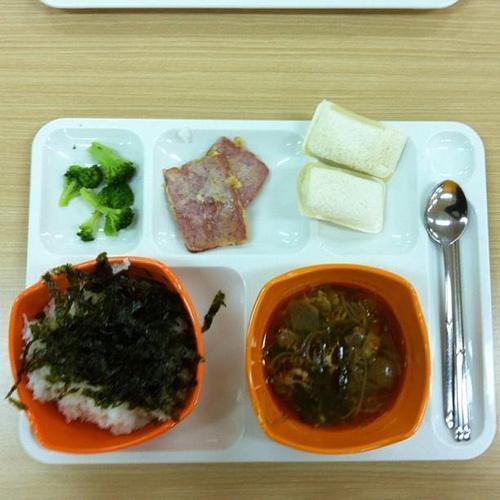How many egg rolls are on the tray?
Give a very brief answer. 2. 